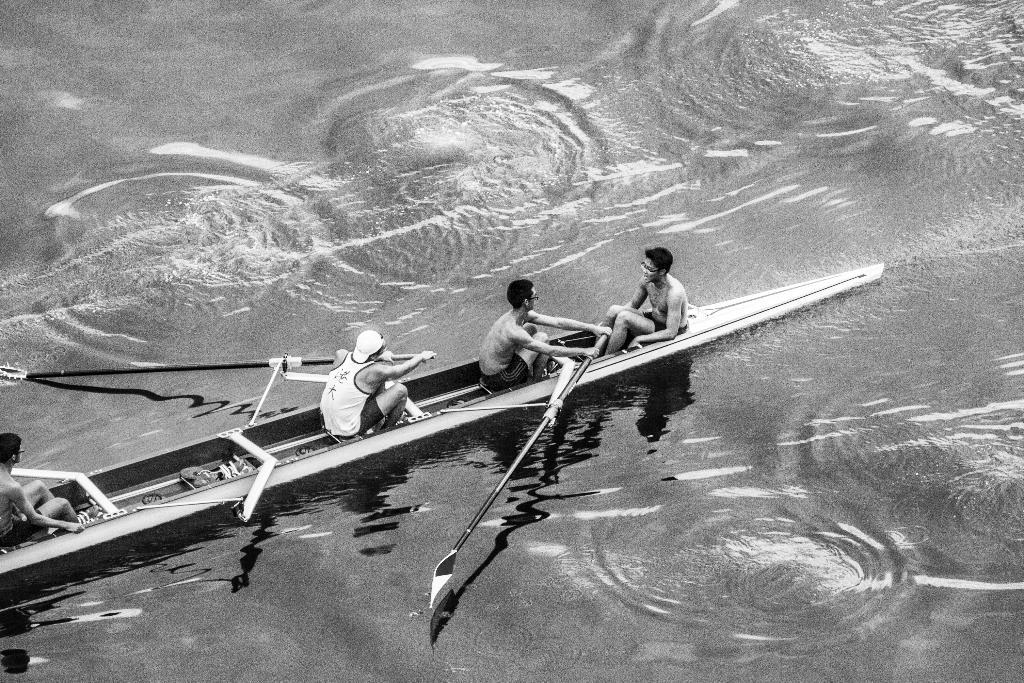What is the main subject of the image? The main subject of the image is a group of people. Where are the people located in the image? The people are sitting on a boat. How many persons are actively riding the boat? There are two persons riding the boat. What can be seen at the bottom of the image? There is water visible at the bottom of the image. What type of fog can be seen surrounding the boat in the image? There is no fog present in the image; it features a group of people sitting on a boat with water visible at the bottom. What songs are the people singing while riding the boat in the image? There is no indication in the image that the people are singing any songs, so it cannot be determined from the picture. 